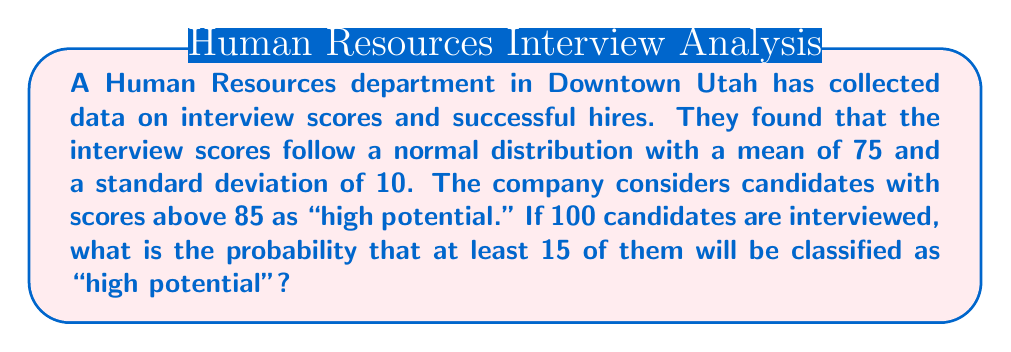Teach me how to tackle this problem. To solve this problem, we'll follow these steps:

1. Find the probability of a single candidate being "high potential"
2. Model the number of "high potential" candidates as a binomial distribution
3. Calculate the probability of at least 15 "high potential" candidates

Step 1: Probability of a single "high potential" candidate
The scores follow a normal distribution with $\mu = 75$ and $\sigma = 10$. We need to find $P(X > 85)$.

First, calculate the z-score:
$$ z = \frac{x - \mu}{\sigma} = \frac{85 - 75}{10} = 1 $$

Using a standard normal table or calculator, we find:
$$ P(Z > 1) = 1 - P(Z < 1) \approx 0.1587 $$

Step 2: Model as binomial distribution
Let $Y$ be the number of "high potential" candidates out of 100. $Y$ follows a binomial distribution with $n = 100$ and $p = 0.1587$.

Step 3: Calculate $P(Y \geq 15)$
We need to find $1 - P(Y < 15)$ or $1 - P(Y \leq 14)$

Using the cumulative binomial probability function:

$$ P(Y \geq 15) = 1 - P(Y \leq 14) = 1 - \sum_{k=0}^{14} \binom{100}{k} (0.1587)^k (1-0.1587)^{100-k} $$

This calculation is complex, so we typically use software or a calculator. Using such a tool, we find:

$$ P(Y \geq 15) \approx 0.7257 $$
Answer: 0.7257 